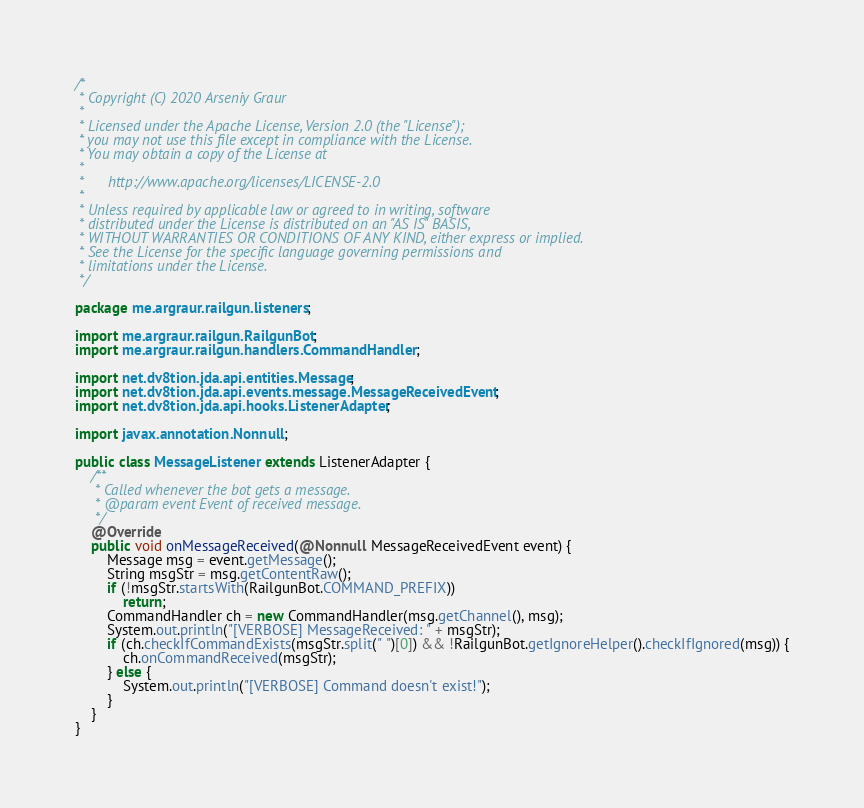<code> <loc_0><loc_0><loc_500><loc_500><_Java_>/*
 * Copyright (C) 2020 Arseniy Graur
 *
 * Licensed under the Apache License, Version 2.0 (the "License");
 * you may not use this file except in compliance with the License.
 * You may obtain a copy of the License at
 *
 *      http://www.apache.org/licenses/LICENSE-2.0
 *
 * Unless required by applicable law or agreed to in writing, software
 * distributed under the License is distributed on an "AS IS" BASIS,
 * WITHOUT WARRANTIES OR CONDITIONS OF ANY KIND, either express or implied.
 * See the License for the specific language governing permissions and
 * limitations under the License.
 */

package me.argraur.railgun.listeners;

import me.argraur.railgun.RailgunBot;
import me.argraur.railgun.handlers.CommandHandler;

import net.dv8tion.jda.api.entities.Message;
import net.dv8tion.jda.api.events.message.MessageReceivedEvent;
import net.dv8tion.jda.api.hooks.ListenerAdapter;

import javax.annotation.Nonnull;

public class MessageListener extends ListenerAdapter {
    /**
     * Called whenever the bot gets a message.
     * @param event Event of received message.
     */
    @Override
    public void onMessageReceived(@Nonnull MessageReceivedEvent event) {
        Message msg = event.getMessage();
        String msgStr = msg.getContentRaw();
        if (!msgStr.startsWith(RailgunBot.COMMAND_PREFIX))
            return;
        CommandHandler ch = new CommandHandler(msg.getChannel(), msg);
        System.out.println("[VERBOSE] MessageReceived: " + msgStr);
        if (ch.checkIfCommandExists(msgStr.split(" ")[0]) && !RailgunBot.getIgnoreHelper().checkIfIgnored(msg)) {
            ch.onCommandReceived(msgStr);
        } else {
            System.out.println("[VERBOSE] Command doesn't exist!");
        }
    }
}
</code> 